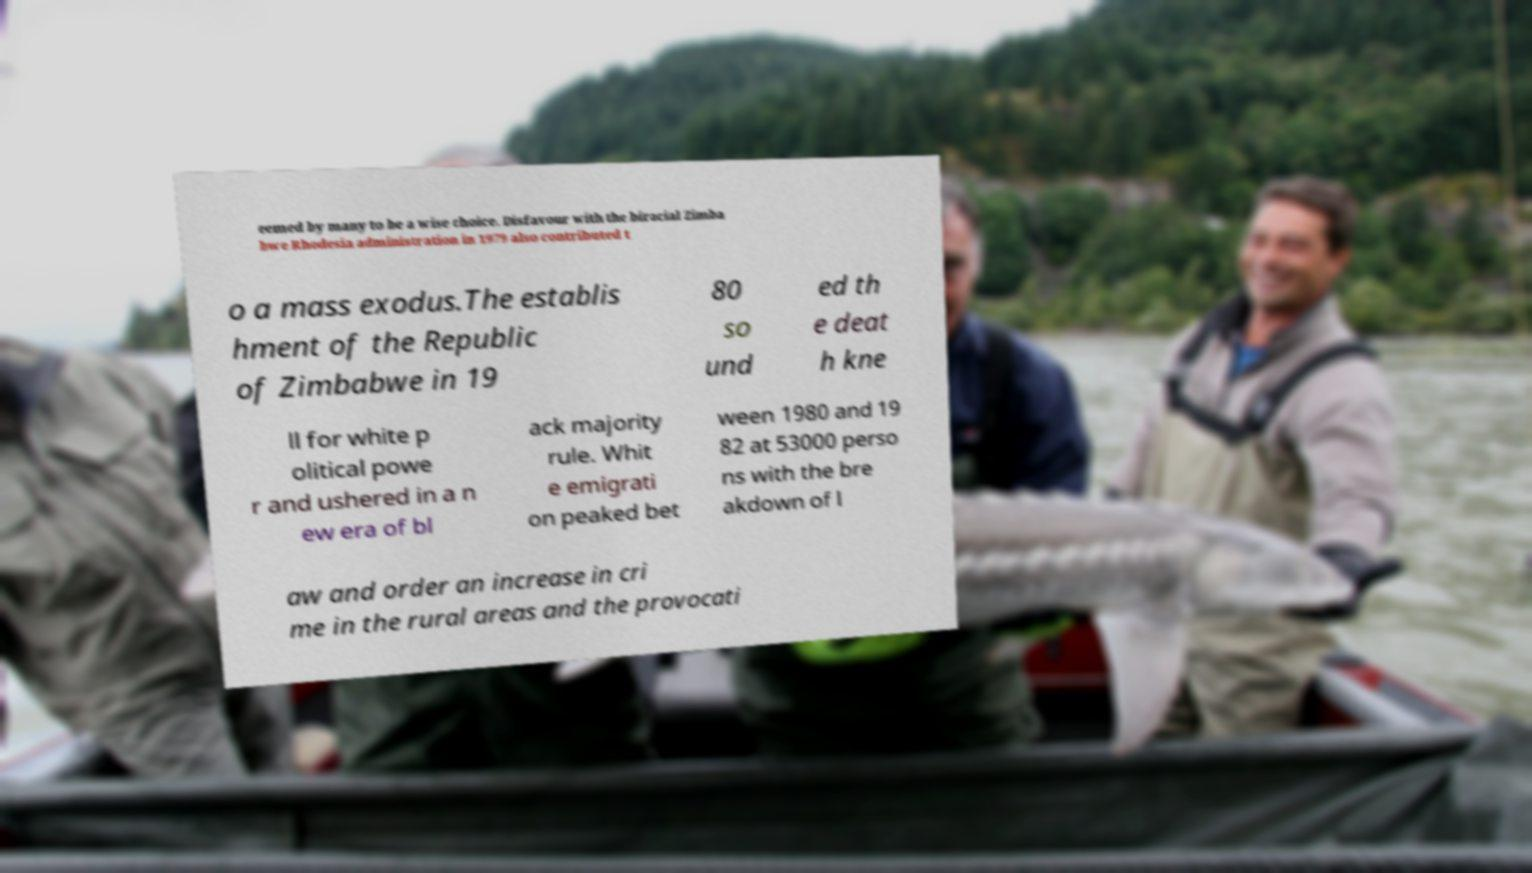Could you assist in decoding the text presented in this image and type it out clearly? eemed by many to be a wise choice. Disfavour with the biracial Zimba bwe Rhodesia administration in 1979 also contributed t o a mass exodus.The establis hment of the Republic of Zimbabwe in 19 80 so und ed th e deat h kne ll for white p olitical powe r and ushered in a n ew era of bl ack majority rule. Whit e emigrati on peaked bet ween 1980 and 19 82 at 53000 perso ns with the bre akdown of l aw and order an increase in cri me in the rural areas and the provocati 